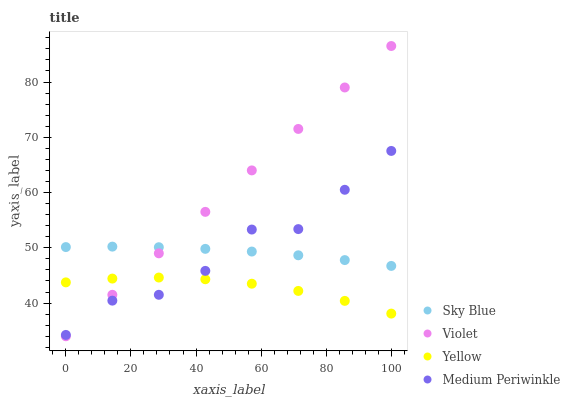Does Yellow have the minimum area under the curve?
Answer yes or no. Yes. Does Violet have the maximum area under the curve?
Answer yes or no. Yes. Does Medium Periwinkle have the minimum area under the curve?
Answer yes or no. No. Does Medium Periwinkle have the maximum area under the curve?
Answer yes or no. No. Is Violet the smoothest?
Answer yes or no. Yes. Is Medium Periwinkle the roughest?
Answer yes or no. Yes. Is Yellow the smoothest?
Answer yes or no. No. Is Yellow the roughest?
Answer yes or no. No. Does Violet have the lowest value?
Answer yes or no. Yes. Does Medium Periwinkle have the lowest value?
Answer yes or no. No. Does Violet have the highest value?
Answer yes or no. Yes. Does Medium Periwinkle have the highest value?
Answer yes or no. No. Is Yellow less than Sky Blue?
Answer yes or no. Yes. Is Sky Blue greater than Yellow?
Answer yes or no. Yes. Does Violet intersect Yellow?
Answer yes or no. Yes. Is Violet less than Yellow?
Answer yes or no. No. Is Violet greater than Yellow?
Answer yes or no. No. Does Yellow intersect Sky Blue?
Answer yes or no. No. 